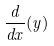Convert formula to latex. <formula><loc_0><loc_0><loc_500><loc_500>\frac { d } { d x } ( y )</formula> 